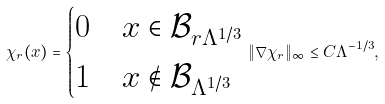<formula> <loc_0><loc_0><loc_500><loc_500>\chi _ { r } ( x ) = \begin{cases} 0 & x \in \mathcal { B } _ { r \Lambda ^ { 1 / 3 } } \\ 1 & x \notin \mathcal { B } _ { \Lambda ^ { 1 / 3 } } \end{cases} \| \nabla \chi _ { r } \| _ { \infty } \leq C \Lambda ^ { - 1 / 3 } ,</formula> 